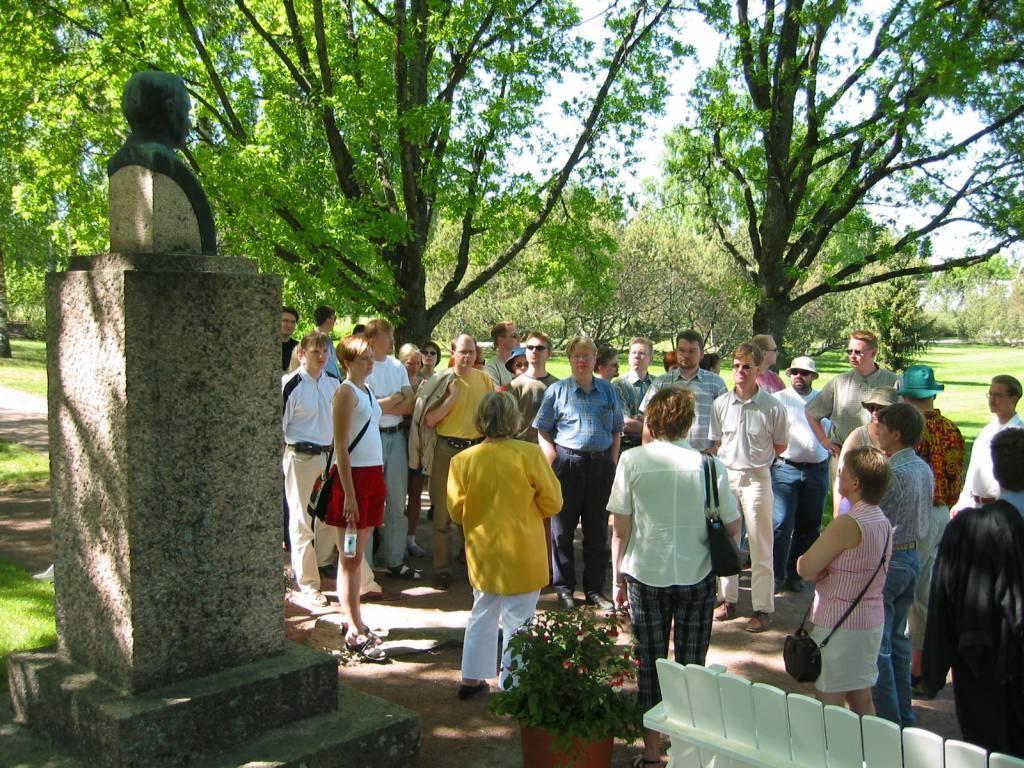Could you give a brief overview of what you see in this image? In this image we can see many people. Some are wearing hats. Some are wearing goggles. Some are having bags. And there is a pot with a plant. In the back there are trees. On the ground there is grass. In the background there is sky. 